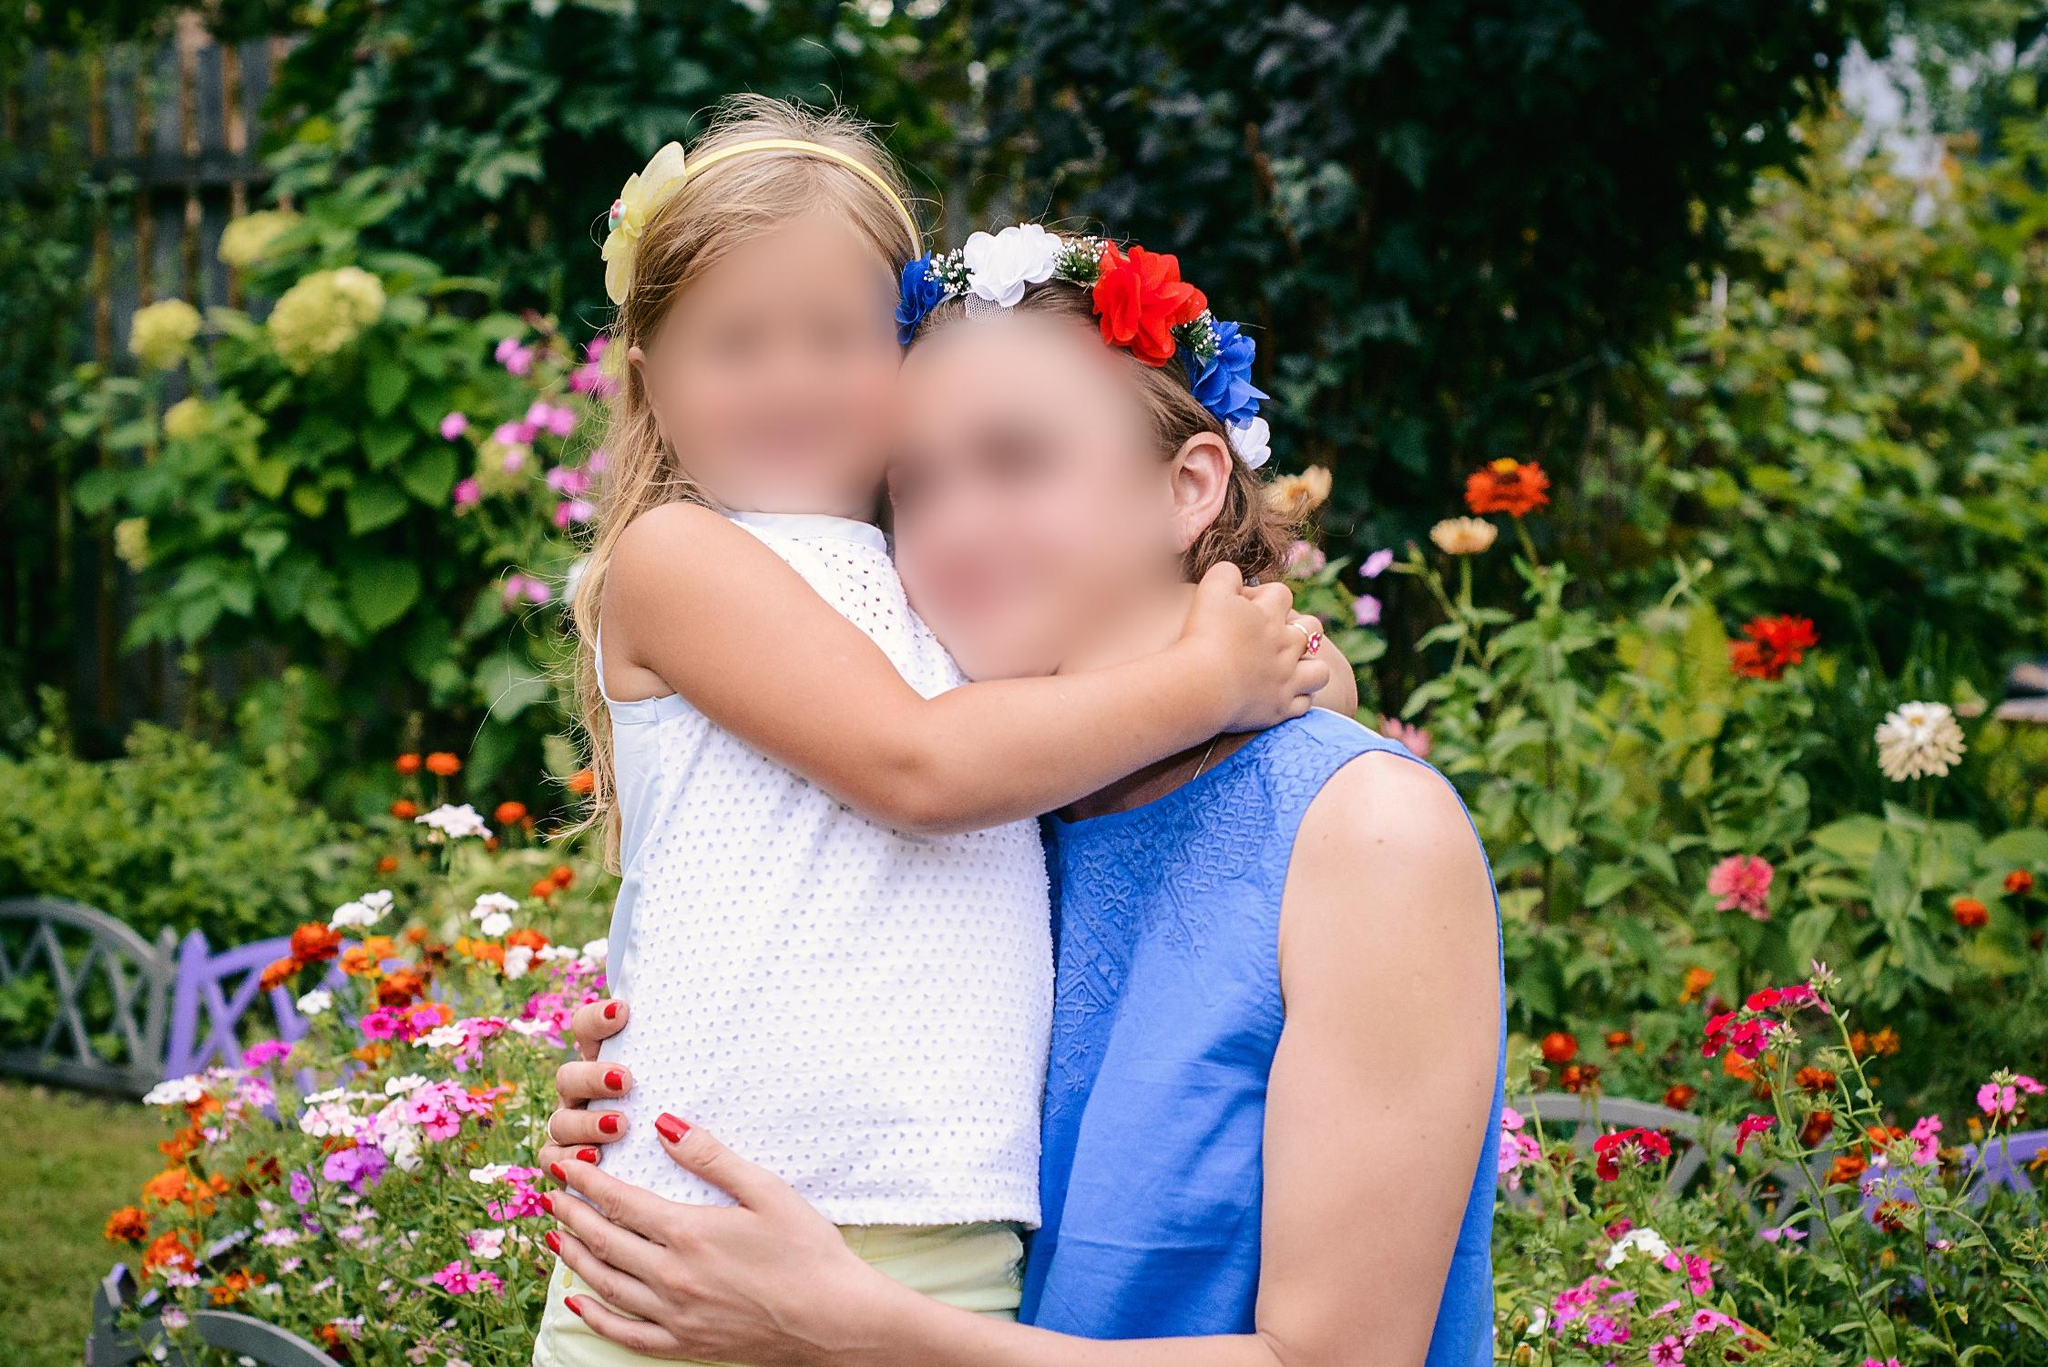What do you see happening in this image? The image depicts a tender moment between a young girl and an older woman in a vibrant garden setting. The girl, dressed in a polka dot white sundress, embraces the woman wearing a blue dress with a floral headband, indicating a joyful or celebratory occasion. Surrounded by a profusion of multi-colored flowers, including reds, pinks, and oranges, and dense green foliage, the scene could likely be a family gathering or a public garden. The warmth of the embrace and the happy expressions suggest a close familial bond, possibly between a grandmother and granddaughter, celebrating a special day outdoors. 